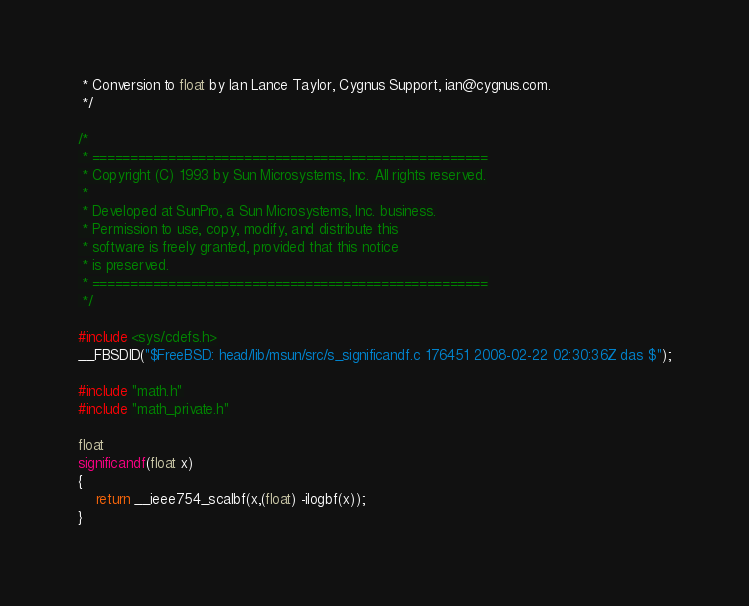<code> <loc_0><loc_0><loc_500><loc_500><_C_> * Conversion to float by Ian Lance Taylor, Cygnus Support, ian@cygnus.com.
 */

/*
 * ====================================================
 * Copyright (C) 1993 by Sun Microsystems, Inc. All rights reserved.
 *
 * Developed at SunPro, a Sun Microsystems, Inc. business.
 * Permission to use, copy, modify, and distribute this
 * software is freely granted, provided that this notice
 * is preserved.
 * ====================================================
 */

#include <sys/cdefs.h>
__FBSDID("$FreeBSD: head/lib/msun/src/s_significandf.c 176451 2008-02-22 02:30:36Z das $");

#include "math.h"
#include "math_private.h"

float
significandf(float x)
{
	return __ieee754_scalbf(x,(float) -ilogbf(x));
}
</code> 